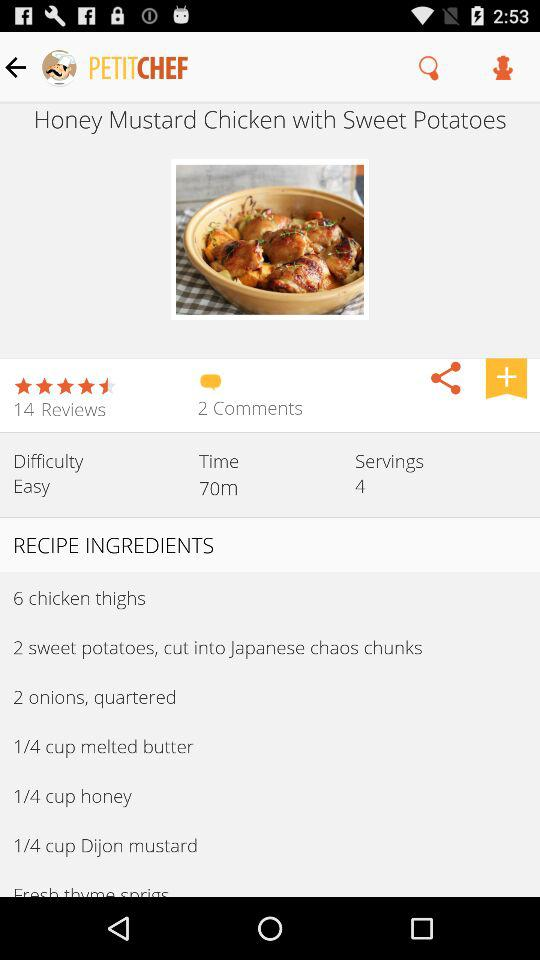What is the name of the application? The name of the application is "PETITCHEF". 